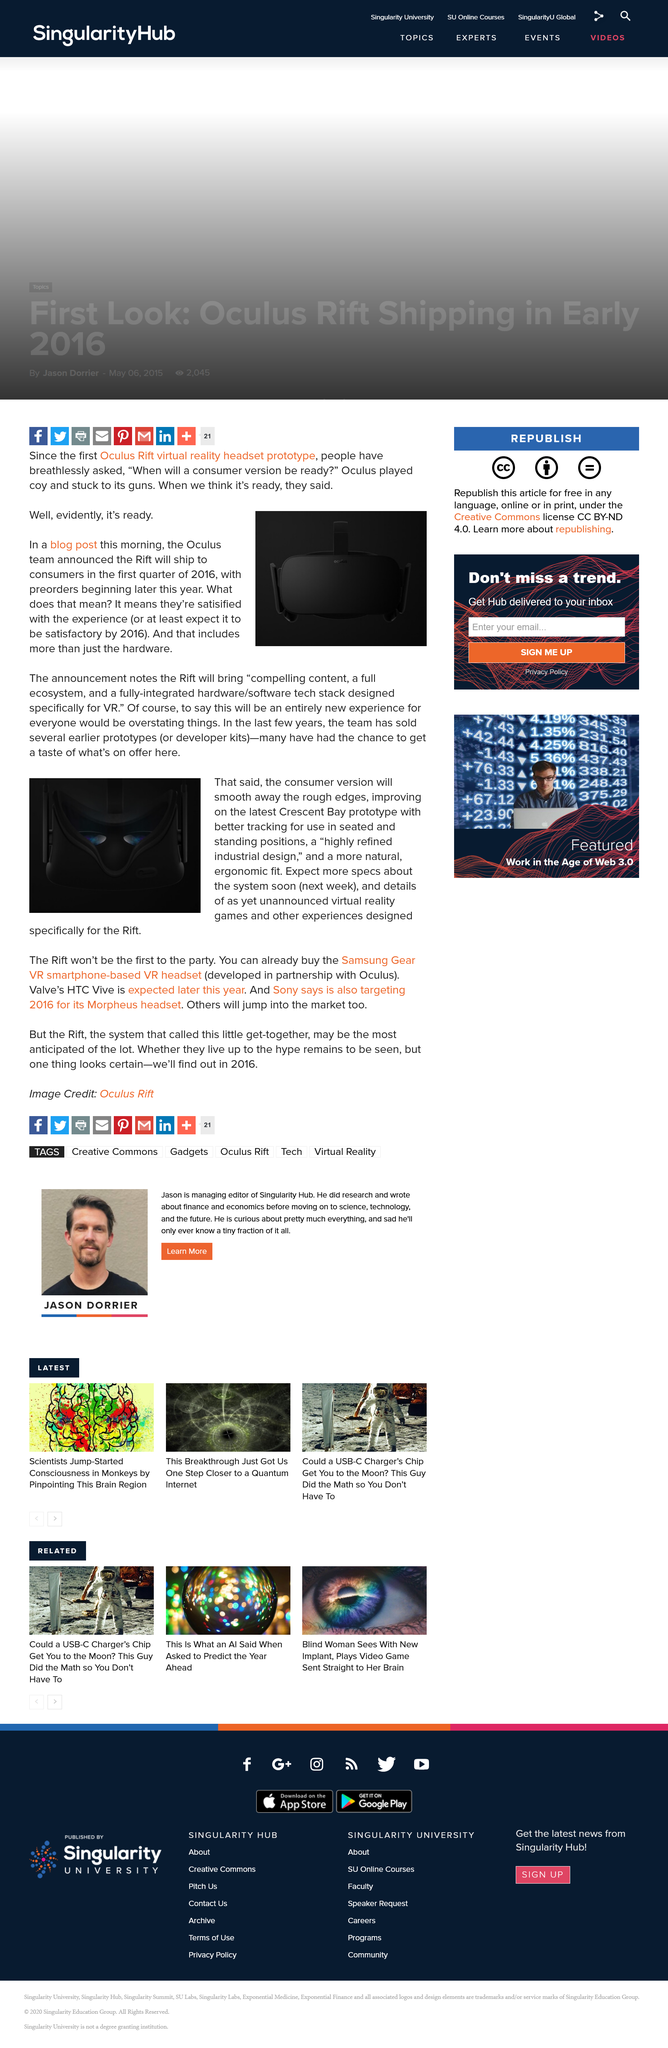Draw attention to some important aspects in this diagram. The release of the first Oculus Rift virtual reality headset prototype prompted consumers to ask, "when will a consumer version be ready? The announcement notes that Rift will bring compelling content, a comprehensive ecosystem, and a technologically advanced hardware/software integration specifically designed for virtual reality. We can anticipate the release of more specific information regarding the new VR system from Rift, the renowned VR brand, in the near future. The latest prototype that they will be improving upon is the Crescent Bay prototype. The first Oculus Rift virtual reality headset prototype is a depiction of a device that represents a new era in technology, revolutionizing the way people interact with computer-generated environments. 